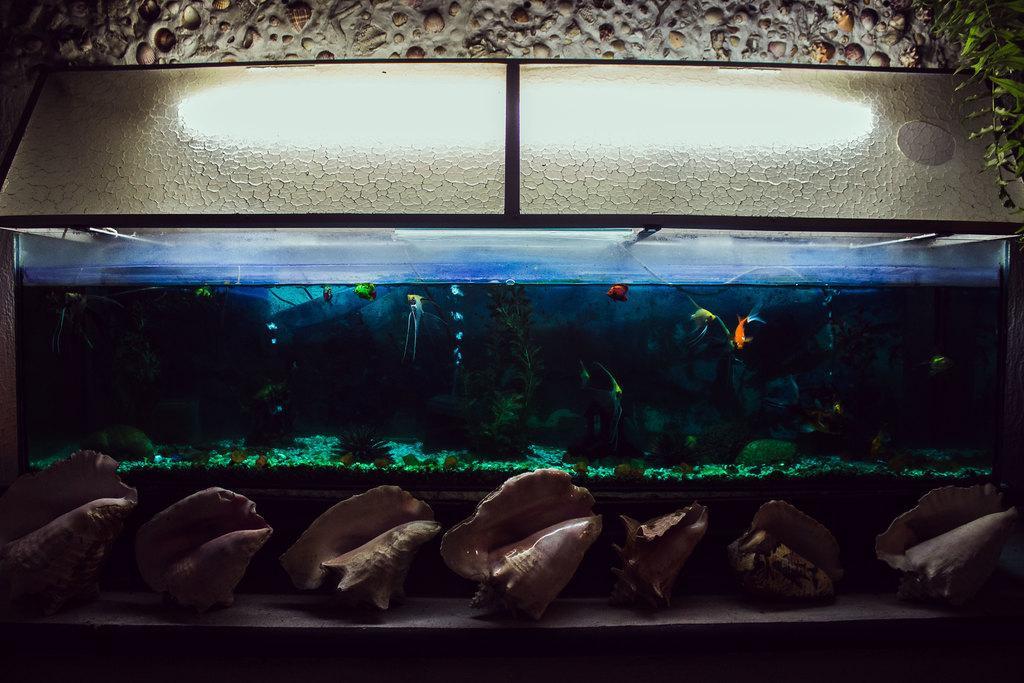In one or two sentences, can you explain what this image depicts? In the foreground of the picture there are shells. In the center of the picture there is an aquarium, in the aquarium there are fishes, water, pebbles and water plants. At the top there is a light and wall. 